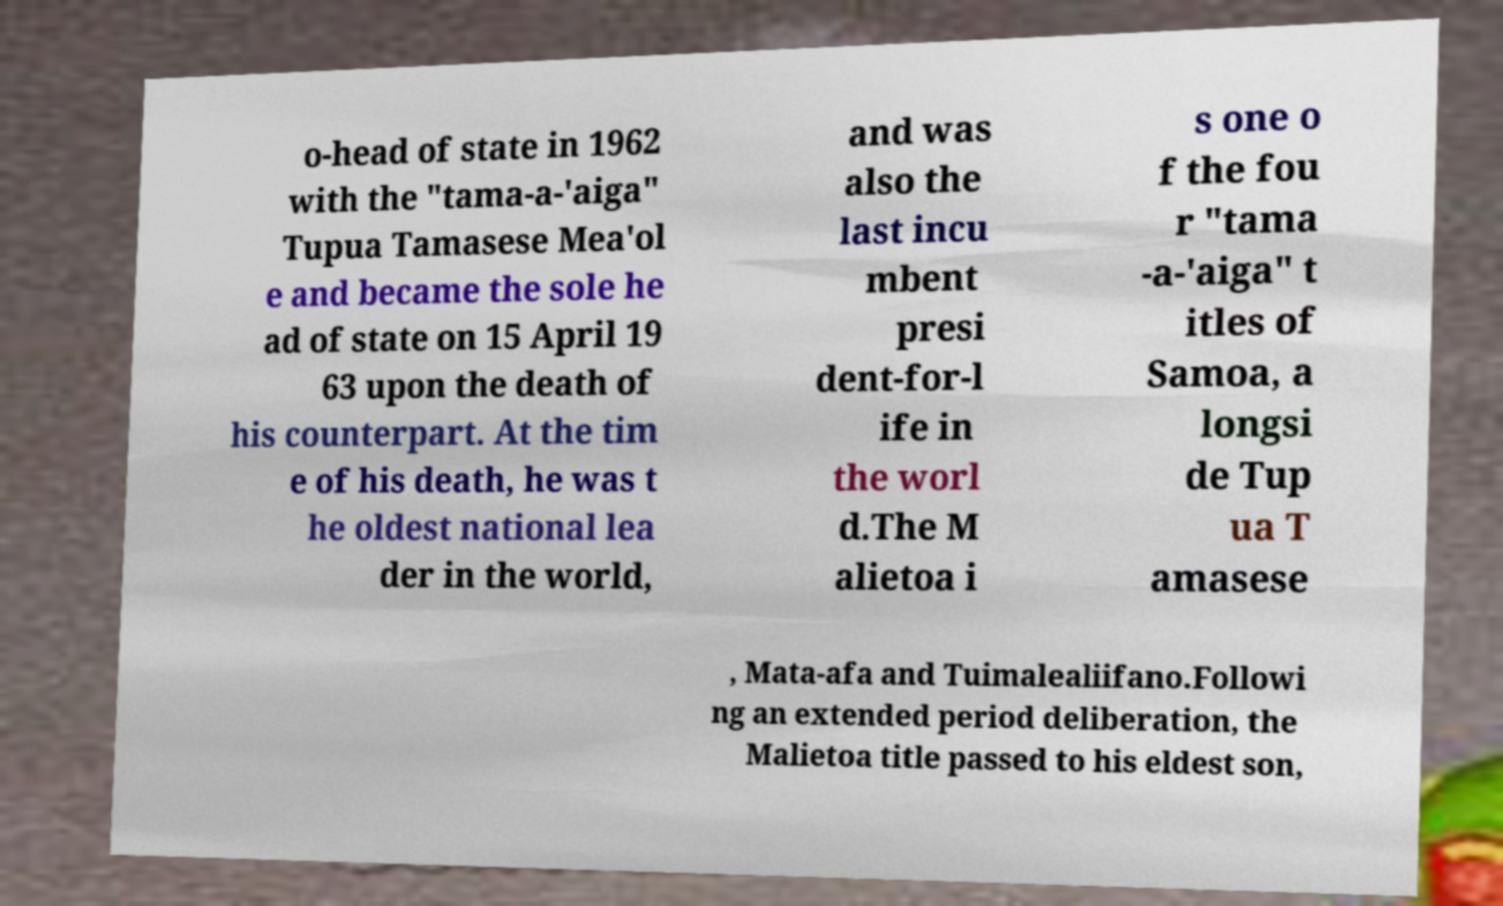Can you accurately transcribe the text from the provided image for me? o-head of state in 1962 with the "tama-a-'aiga" Tupua Tamasese Mea'ol e and became the sole he ad of state on 15 April 19 63 upon the death of his counterpart. At the tim e of his death, he was t he oldest national lea der in the world, and was also the last incu mbent presi dent-for-l ife in the worl d.The M alietoa i s one o f the fou r "tama -a-'aiga" t itles of Samoa, a longsi de Tup ua T amasese , Mata-afa and Tuimalealiifano.Followi ng an extended period deliberation, the Malietoa title passed to his eldest son, 